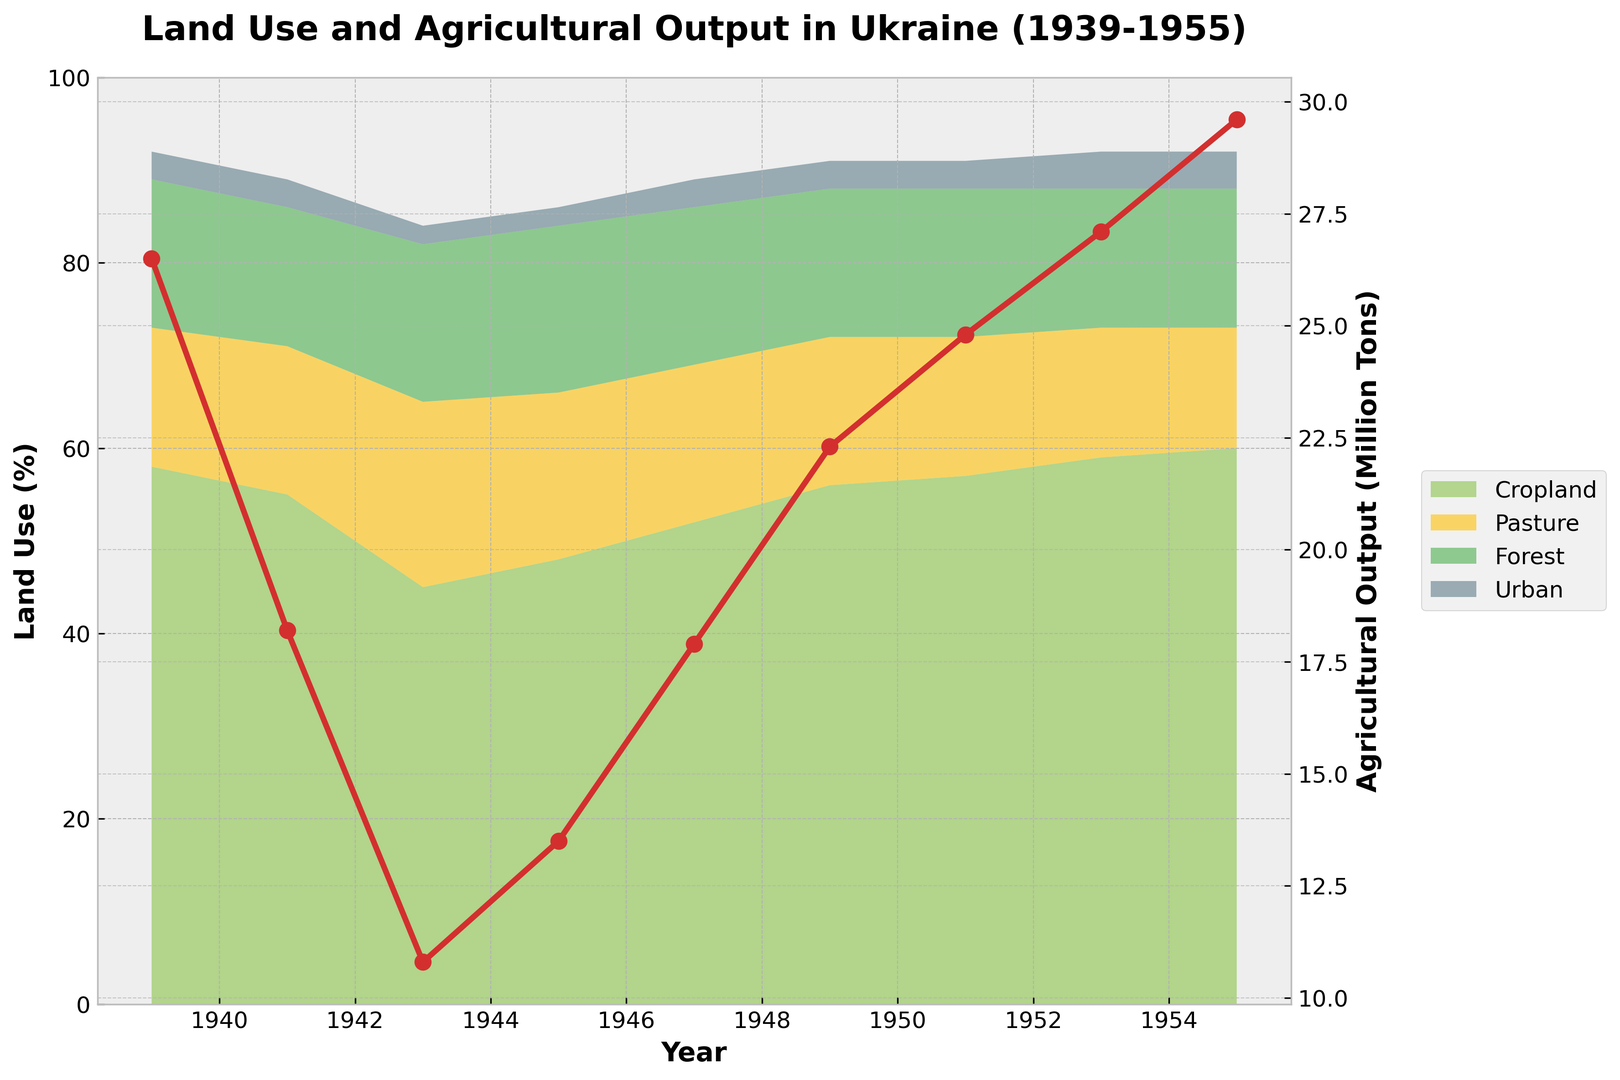What year had the lowest agricultural output, and what was the output in that year? By examining the red line on the right y-axis of the chart, we can see the lowest agricultural output in 1943. The corresponding value at the lowest point is 10.8 million tons.
Answer: 1943, 10.8 million tons Which type of land use had the most significant decrease between 1939 and 1943? Cropland decreased from 58% to 45%, Pasture increased overall, Forest had minimal change from 16% to 17%, and Urban decreased minimally from 3% to 2%. The most significant change is in Cropland.
Answer: Cropland How much did agricultural output increase between 1943 and 1953? The agricultural output in 1943 was 10.8 million tons and in 1953 it was 27.1 million tons. The increase can be calculated as 27.1 - 10.8 = 16.3 million tons.
Answer: 16.3 million tons In which year did Urban land use start to increase and what was its value before and after the increase? Urban land use value started increasing from 1951 to 1953. It was at 3% before the increase and changed to 4% post-1951.
Answer: 1951, 3%, 4% How did pasture land use change from 1939 to 1955 and what could be the potential reasons? The pasture land decreased from 15% in 1939 to 13% in 1955. To understand potential reasons, one could consider socio-economic changes or recovery stages post-war.
Answer: Decreased from 15% to 13% Which year saw the maximum increase in Agricultural Output compared to the previous year, and what was the increase? The year 1949 saw an increase from 17.9 million tons in 1947 to 22.3 million tons in 1949. The increase is calculated as 22.3 - 17.9 = 4.4 million tons.
Answer: 1949, 4.4 million tons What can be inferred about the relationship between Cropland and Agricultural Output from 1939 to 1955? Generally, an increase in Cropland correlates with an increase in Agricultural Output, except for some war-affected years (e.g., 1941-1943).
Answer: Positive correlation What was the trend in Forest land use over the period 1939 to 1955, and how might this impact agricultural practices? Forest land use remained relatively stable, starting at 16% in 1939 and ending at 15% in 1955, with minor fluctuations. Stability in forestry can maintain biodiversity and soil health, beneficial for agriculture.
Answer: Stable, 16% to 15% Which year had the highest percentage of Cropland, and how much did it contribute to the total land use? The year 1955 had the highest percentage of Cropland at 60% of the total land use.
Answer: 1955, 60% 